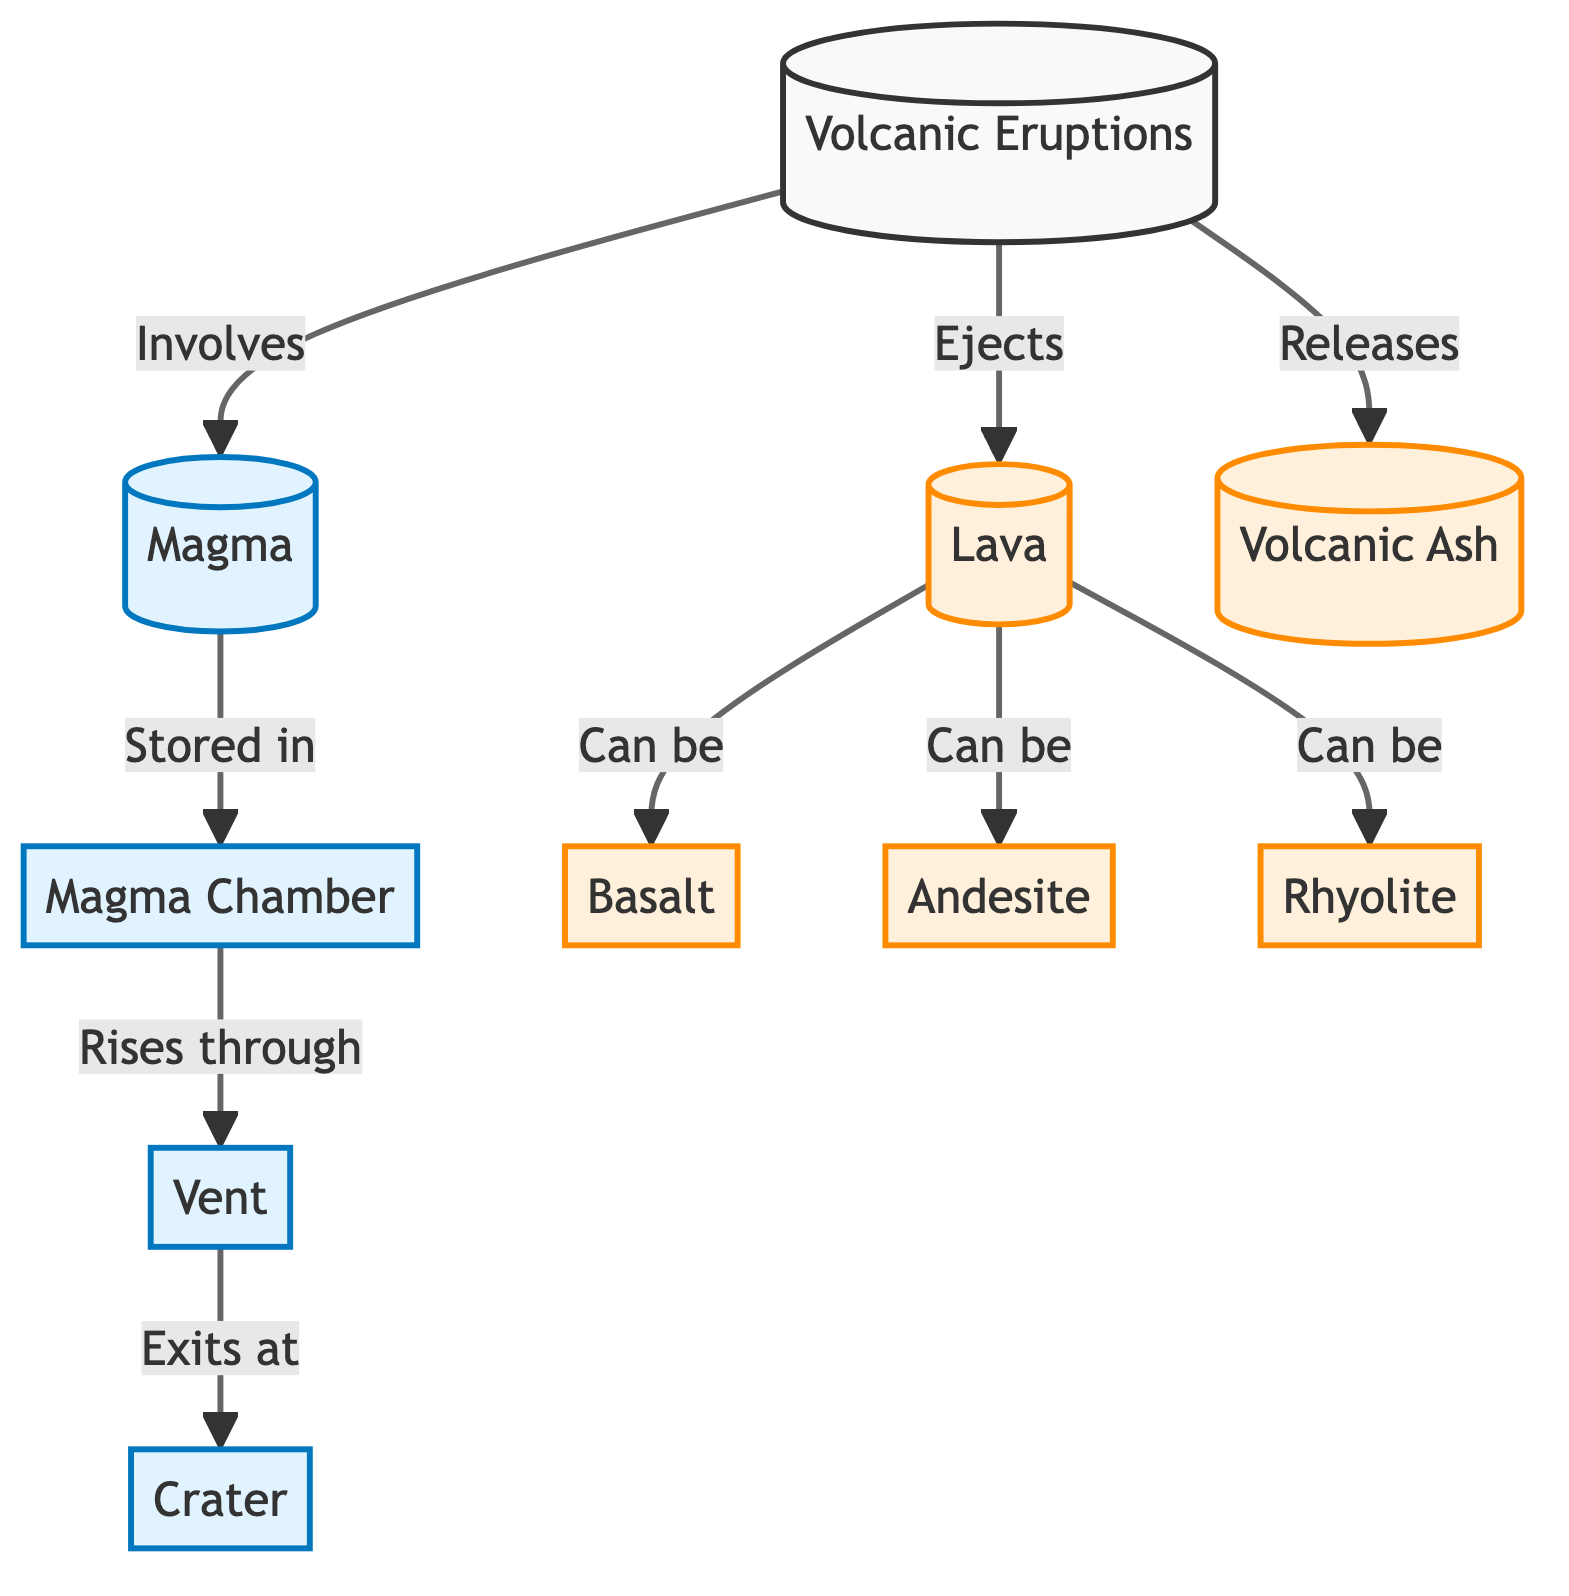What is the main subject of the diagram? The diagram focuses on volcanic eruptions, depicting the relationships between magma, lava, and volcanic ash. The first node clearly states "Volcanic Eruptions," indicating that it is the central topic.
Answer: Volcanic Eruptions How many types of outputs are shown in the diagram? The diagram lists three types of outputs that can result from a volcanic eruption: basalt, andesite, and rhyolite. These are linked to the lava node, clearly indicating their categorization.
Answer: 3 What is stored in the magma chamber? The magma chamber is directly connected to the magma node, indicating that magma is stored there before it rises. This is a straightforward connection shown in the diagram.
Answer: Magma What is the sequence of the eruption process from magma to lava? The process starts with magma being stored in the magma chamber, it then rises through the vent, exits at the crater, and finally is ejected as lava. The flow arrows in the diagram outline this order.
Answer: Magma, Vent, Crater, Lava What types of lava can occur according to the diagram? The diagram specifies three types of lava: basalt, andesite, and rhyolite. These are labeled outputs from the lava node, illustrating the potential forms lava can take post-eruption.
Answer: Basalt, Andesite, Rhyolite Which node is directly linked to the magma chamber? The vent is the next node directly linked to the magma chamber. The arrows in the diagram show that magma flows from the chamber to the vent as part of the eruption process.
Answer: Vent How does lava exit the volcano? Lava exits the volcano through the crater, as indicated by the arrow pointing from the vent to the crater. This clear directional flow demonstrates how the material progresses.
Answer: Crater What relation does volcanic ash have to volcanic eruptions? Volcanic ash is released during eruptive activity, serving as one of the outputs indicated in the diagram. This output is directly linked to the volcanic eruptions node.
Answer: Releases What type of process is magma movement through the vent classified as? The movement of magma from the magma chamber through the vent can be classified as a process, as demonstrated by its connection and label in the diagram.
Answer: Process 